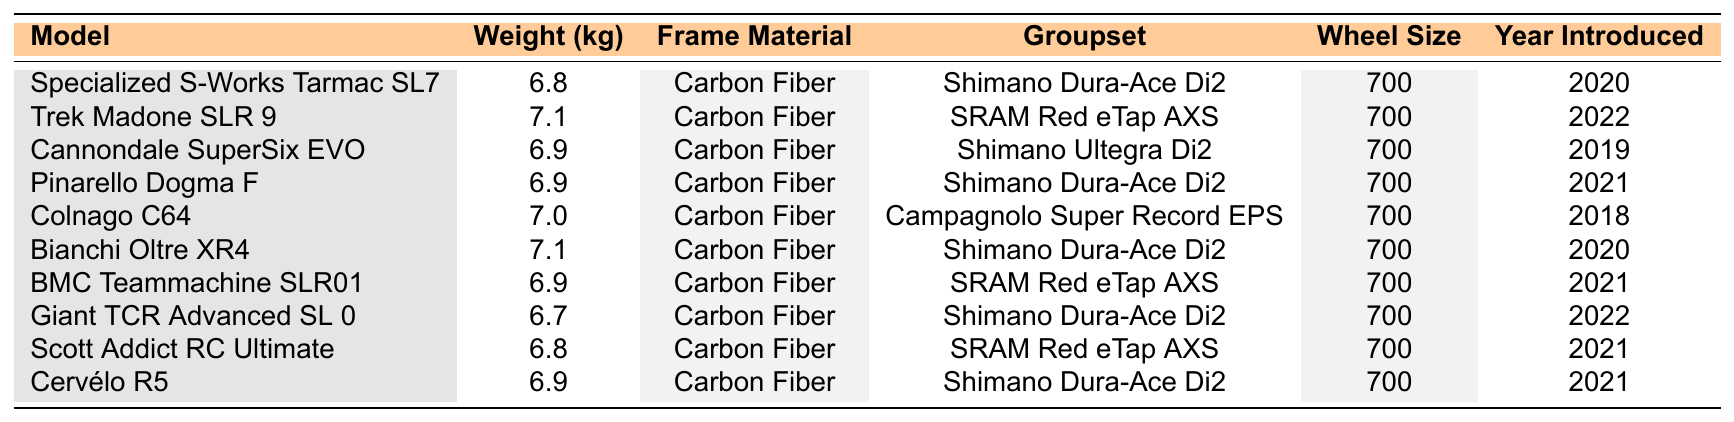What is the lightest bicycle model in the table? The table lists several bicycle models with their weights. Looking through the weight column, the lightest model is the Giant TCR Advanced SL 0 at 6.7 kg.
Answer: Giant TCR Advanced SL 0 Which groupset is used by the most bicycle models in the table? By scanning the "Groupset" column, it's evident that Shimano Dura-Ace Di2 appears four times, while SRAM Red eTap AXS appears three times and Shimano Ultegra Di2 appears once. Therefore, Dura-Ace Di2 is the most common groupset.
Answer: Shimano Dura-Ace Di2 What is the average weight of the bicycles listed in the table? To calculate the average weight, sum up all the weights (6.8 + 7.1 + 6.9 + 6.9 + 7.0 + 7.1 + 6.9 + 6.7 + 6.8 + 6.9) which totals 69.3 kg. There are 10 models, so dividing by 10 gives 69.3 / 10 = 6.93 kg.
Answer: 6.93 kg Has any model been introduced in 2021? The table shows multiple entries from various years. Checking the "Year Introduced" column reveals that there are models introduced in 2021: Pinarello Dogma F, BMC Teammachine SLR01, Scott Addict RC Ultimate, and Cervélo R5. Hence, the answer is yes.
Answer: Yes What is the difference in weight between the heaviest and lightest bicycle models? The heaviest bicycle is the Trek Madone SLR 9 at 7.1 kg, and the lightest is the Giant TCR Advanced SL 0 at 6.7 kg. Thus, the difference is calculated as 7.1 kg - 6.7 kg = 0.4 kg.
Answer: 0.4 kg Are there any bicycle models with a frame material that is not carbon fiber? In checking the "Frame Material" column, all the listed models have carbon fiber as their material. Consequently, there are no alternative materials present in the table.
Answer: No Which group has bicycles introduced before 2020? By inspecting the "Year Introduced" column, the only model introduced before 2020 is the Colnago C64 from 2018. Therefore, the answer involves having at least one model in that category.
Answer: Yes How many bicycle models weigh between 6.8 kg and 7.0 kg inclusive? Looking at the weights, the models fitting within this range are the Specialized S-Works Tarmac SL7 at 6.8 kg, Cannondale SuperSix EVO at 6.9 kg, Pinarello Dogma F at 6.9 kg, BMC Teammachine SLR01 at 6.9 kg, Scott Addict RC Ultimate at 6.8 kg, and Cervélo R5 at 6.9 kg. This totals to 6 models.
Answer: 6 Which model has been introduced most recently? Upon reviewing the "Year Introduced" column, the Trek Madone SLR 9 is the most recent, introduced in 2022. Therefore, the answer is based on the latest year listed.
Answer: Trek Madone SLR 9 What materials are used for the frames of bicycles introduced in 2020? The models introduced in 2020 are Specialized S-Works Tarmac SL7 and Bianchi Oltre XR4. Both of them use carbon fiber for their frames, as indicated in the "Frame Material" column. Therefore, the material remains consistent across these models.
Answer: Carbon Fiber 